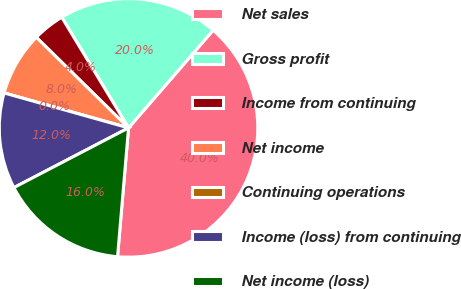<chart> <loc_0><loc_0><loc_500><loc_500><pie_chart><fcel>Net sales<fcel>Gross profit<fcel>Income from continuing<fcel>Net income<fcel>Continuing operations<fcel>Income (loss) from continuing<fcel>Net income (loss)<nl><fcel>40.0%<fcel>20.0%<fcel>4.0%<fcel>8.0%<fcel>0.0%<fcel>12.0%<fcel>16.0%<nl></chart> 